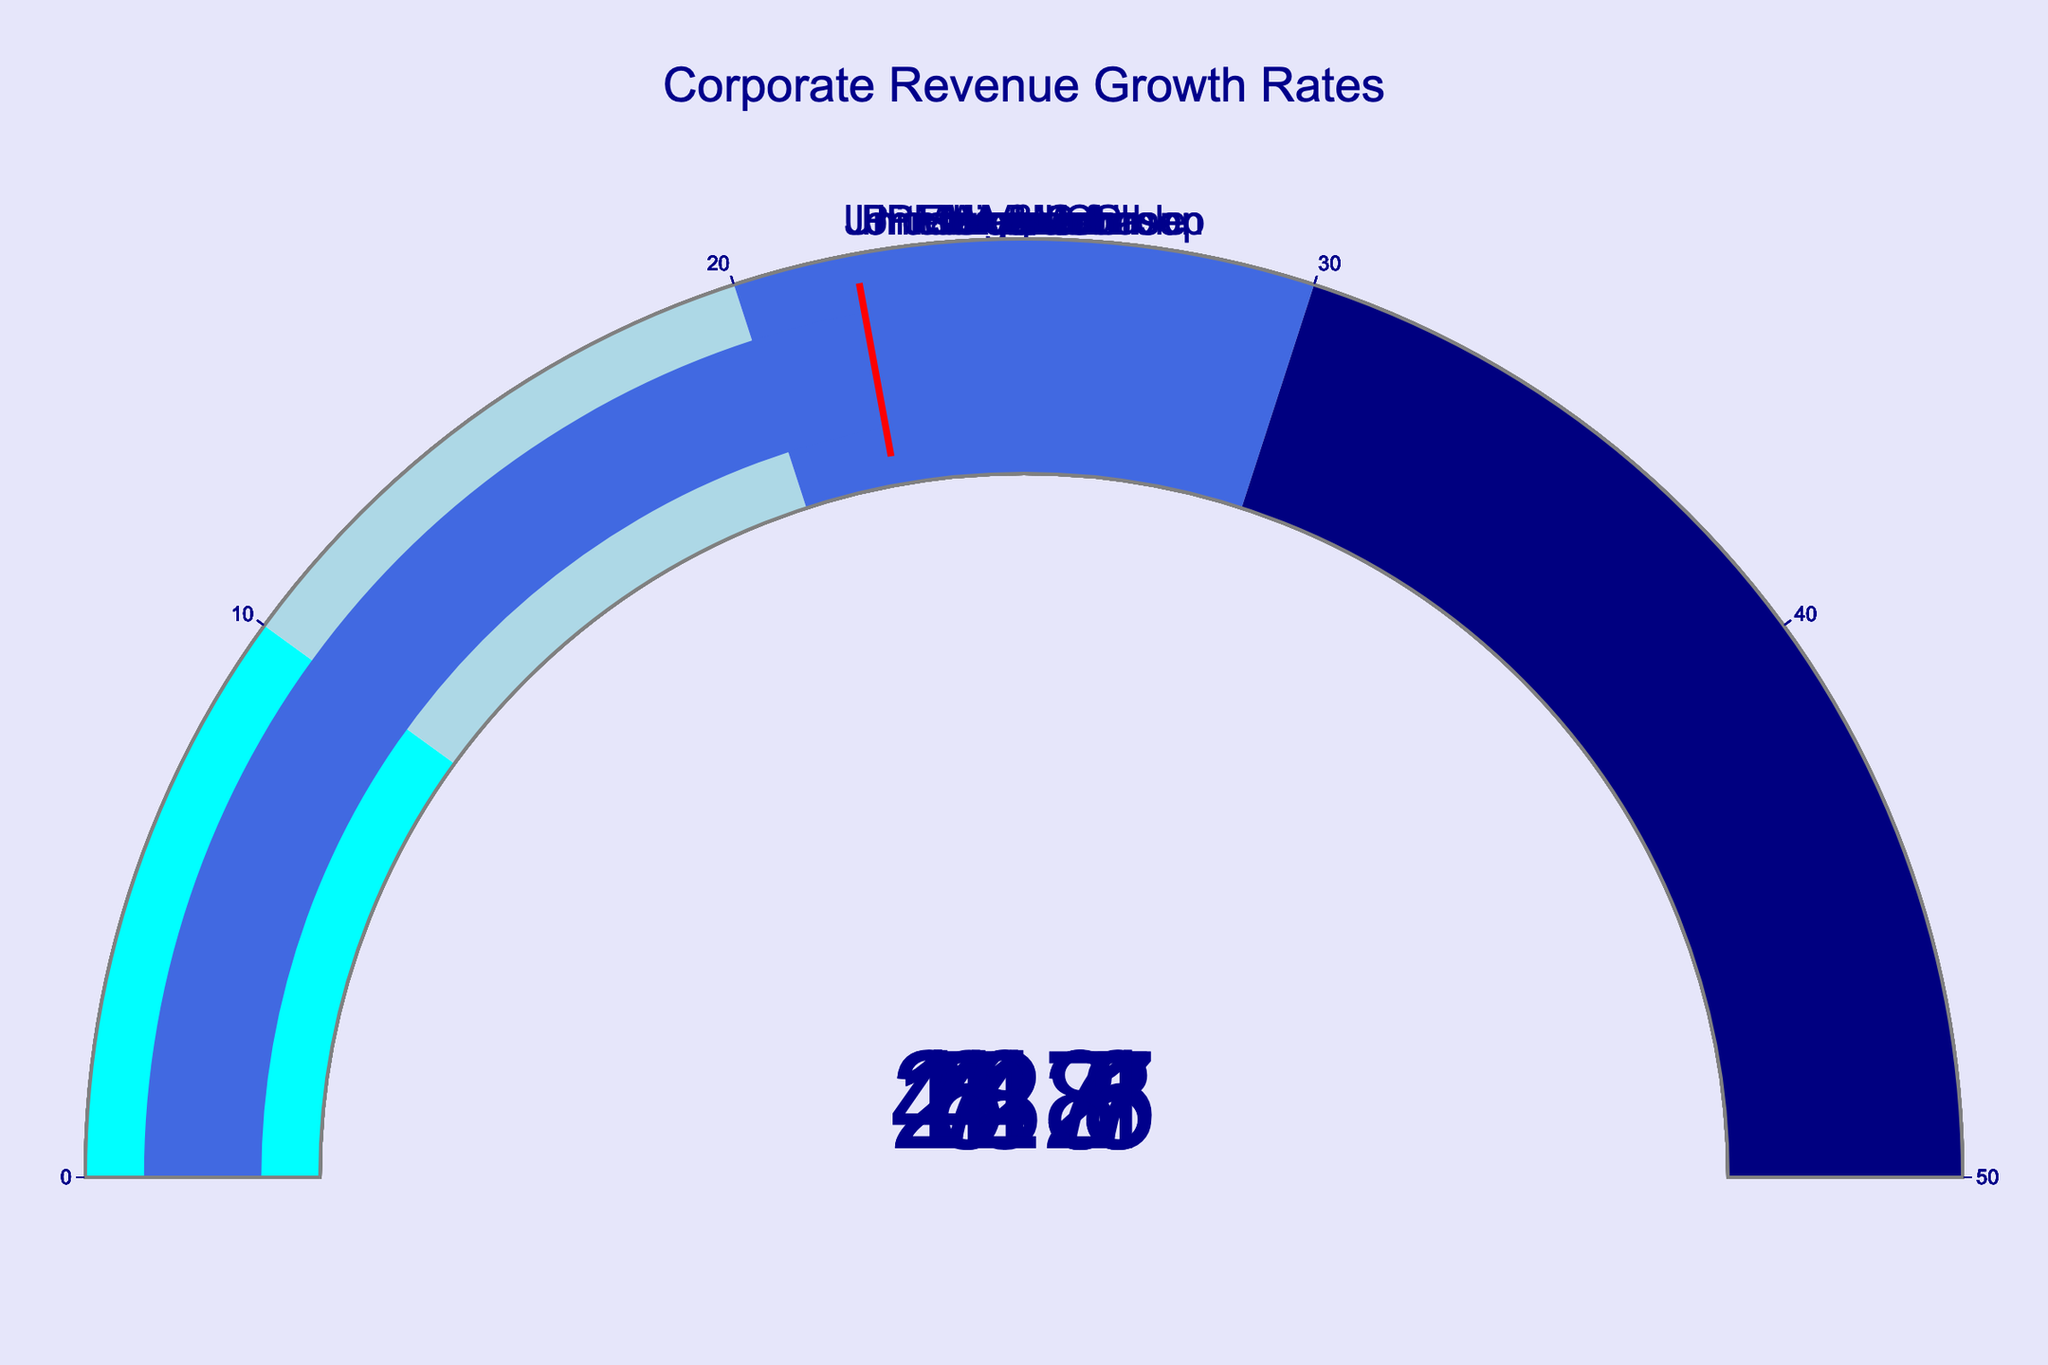Which company has the highest revenue growth rate? To find the company with the highest revenue growth rate, look at the gauges and identify the one with the highest value. The highest value is 44.8, belonging to ExxonMobil.
Answer: ExxonMobil What is the average revenue growth rate of all companies? Add up all the revenue growth rates: 21.5 (Amazon) + 18.3 (Microsoft) + 7.8 (Apple) + 6.7 (Walmart) + 4.2 (JPMorgan Chase) + 44.8 (ExxonMobil) + 12.7 (UnitedHealth Group) + 1.3 (Johnson & Johnson) + 5.3 (Procter & Gamble) + 22.1 (Visa) = 144.7. Divide by the number of companies (10): 144.7 / 10 = 14.47.
Answer: 14.47% Which company has a revenue growth rate closest to the average? The average revenue growth rate is 14.47%. Compare this to each company's rate: Amazon (21.5), Microsoft (18.3), Apple (7.8), Walmart (6.7), JPMorgan Chase (4.2), ExxonMobil (44.8), UnitedHealth Group (12.7), Johnson & Johnson (1.3), Procter & Gamble (5.3), Visa (22.1). UnitedHealth Group at 12.7% is closest to the average.
Answer: UnitedHealth Group How many companies have a revenue growth rate below 10%? Identify the companies with revenue growth rates under 10%: Apple (7.8), Walmart (6.7), JPMorgan Chase (4.2), Johnson & Johnson (1.3), Procter & Gamble (5.3). There are 5 companies.
Answer: 5 What is the difference in revenue growth rate between Visa and JPMorgan Chase? Subtract the revenue growth rate of JPMorgan Chase from Visa: 22.1 (Visa) - 4.2 (JPMorgan Chase) = 17.9.
Answer: 17.9% What color indicates the highest range of revenue growth rate on the gauges? The highest range of revenue growth rate on the gauges is 30 to 50, which is indicated by the color navy.
Answer: Navy Which company has a revenue growth rate that is twice the rate of Apple? Apple's growth rate is 7.8%. Doubling 7.8% gives 15.6%. None of the companies have exactly 15.6%, so we need the closest higher value, which is Microsoft at 18.3%.
Answer: Microsoft What is the median revenue growth rate among all companies? List the revenue growth rates in ascending order: 1.3 (Johnson & Johnson), 4.2 (JPMorgan Chase), 5.3 (Procter & Gamble), 6.7 (Walmart), 7.8 (Apple), 12.7 (UnitedHealth Group), 18.3 (Microsoft), 21.5 (Amazon), 22.1 (Visa), 44.8 (ExxonMobil). The middle values are 7.8 and 12.7; the median is (7.8 + 12.7) / 2 = 10.25.
Answer: 10.25% How does Procter & Gamble's revenue growth rate compare to Walmart's? Procter & Gamble has a revenue growth rate of 5.3%, and Walmart has a rate of 6.7%. Compare the two: 5.3% < 6.7%.
Answer: Less 